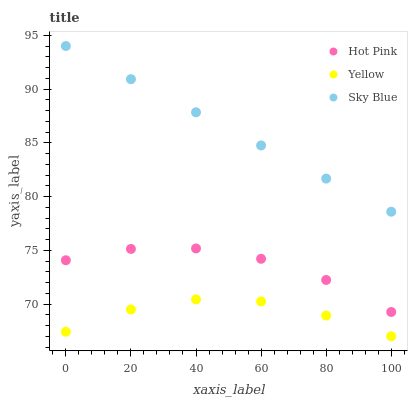Does Yellow have the minimum area under the curve?
Answer yes or no. Yes. Does Sky Blue have the maximum area under the curve?
Answer yes or no. Yes. Does Hot Pink have the minimum area under the curve?
Answer yes or no. No. Does Hot Pink have the maximum area under the curve?
Answer yes or no. No. Is Sky Blue the smoothest?
Answer yes or no. Yes. Is Hot Pink the roughest?
Answer yes or no. Yes. Is Yellow the smoothest?
Answer yes or no. No. Is Yellow the roughest?
Answer yes or no. No. Does Yellow have the lowest value?
Answer yes or no. Yes. Does Hot Pink have the lowest value?
Answer yes or no. No. Does Sky Blue have the highest value?
Answer yes or no. Yes. Does Hot Pink have the highest value?
Answer yes or no. No. Is Yellow less than Sky Blue?
Answer yes or no. Yes. Is Sky Blue greater than Yellow?
Answer yes or no. Yes. Does Yellow intersect Sky Blue?
Answer yes or no. No. 